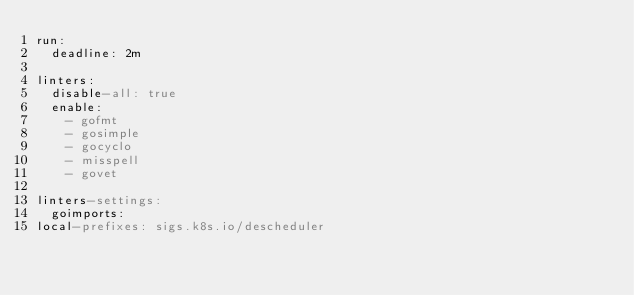<code> <loc_0><loc_0><loc_500><loc_500><_YAML_>run:
  deadline: 2m

linters:
  disable-all: true
  enable:
    - gofmt
    - gosimple
    - gocyclo
    - misspell
    - govet

linters-settings:
  goimports:
local-prefixes: sigs.k8s.io/descheduler
</code> 